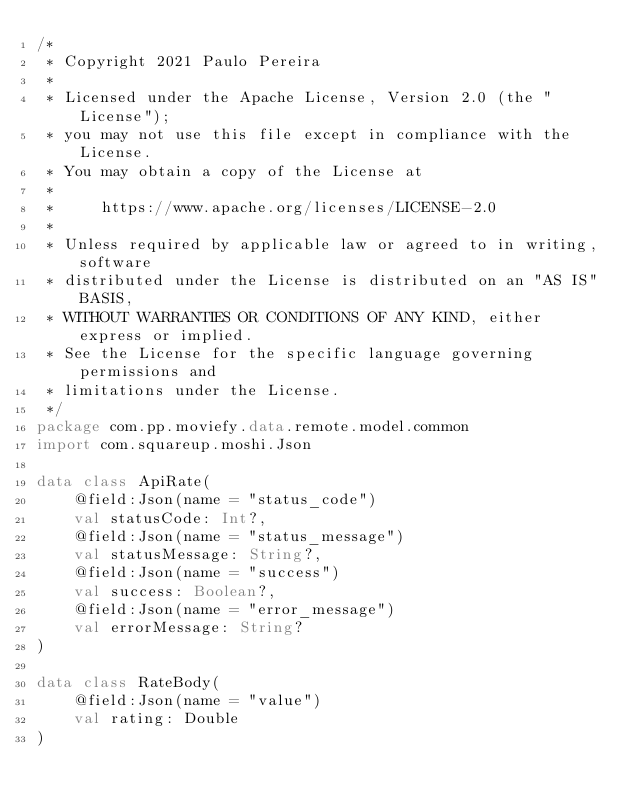Convert code to text. <code><loc_0><loc_0><loc_500><loc_500><_Kotlin_>/*
 * Copyright 2021 Paulo Pereira
 *
 * Licensed under the Apache License, Version 2.0 (the "License");
 * you may not use this file except in compliance with the License.
 * You may obtain a copy of the License at
 *
 *     https://www.apache.org/licenses/LICENSE-2.0
 *
 * Unless required by applicable law or agreed to in writing, software
 * distributed under the License is distributed on an "AS IS" BASIS,
 * WITHOUT WARRANTIES OR CONDITIONS OF ANY KIND, either express or implied.
 * See the License for the specific language governing permissions and
 * limitations under the License.
 */
package com.pp.moviefy.data.remote.model.common
import com.squareup.moshi.Json

data class ApiRate(
    @field:Json(name = "status_code")
    val statusCode: Int?,
    @field:Json(name = "status_message")
    val statusMessage: String?,
    @field:Json(name = "success")
    val success: Boolean?,
    @field:Json(name = "error_message")
    val errorMessage: String?
)

data class RateBody(
    @field:Json(name = "value")
    val rating: Double
)
</code> 